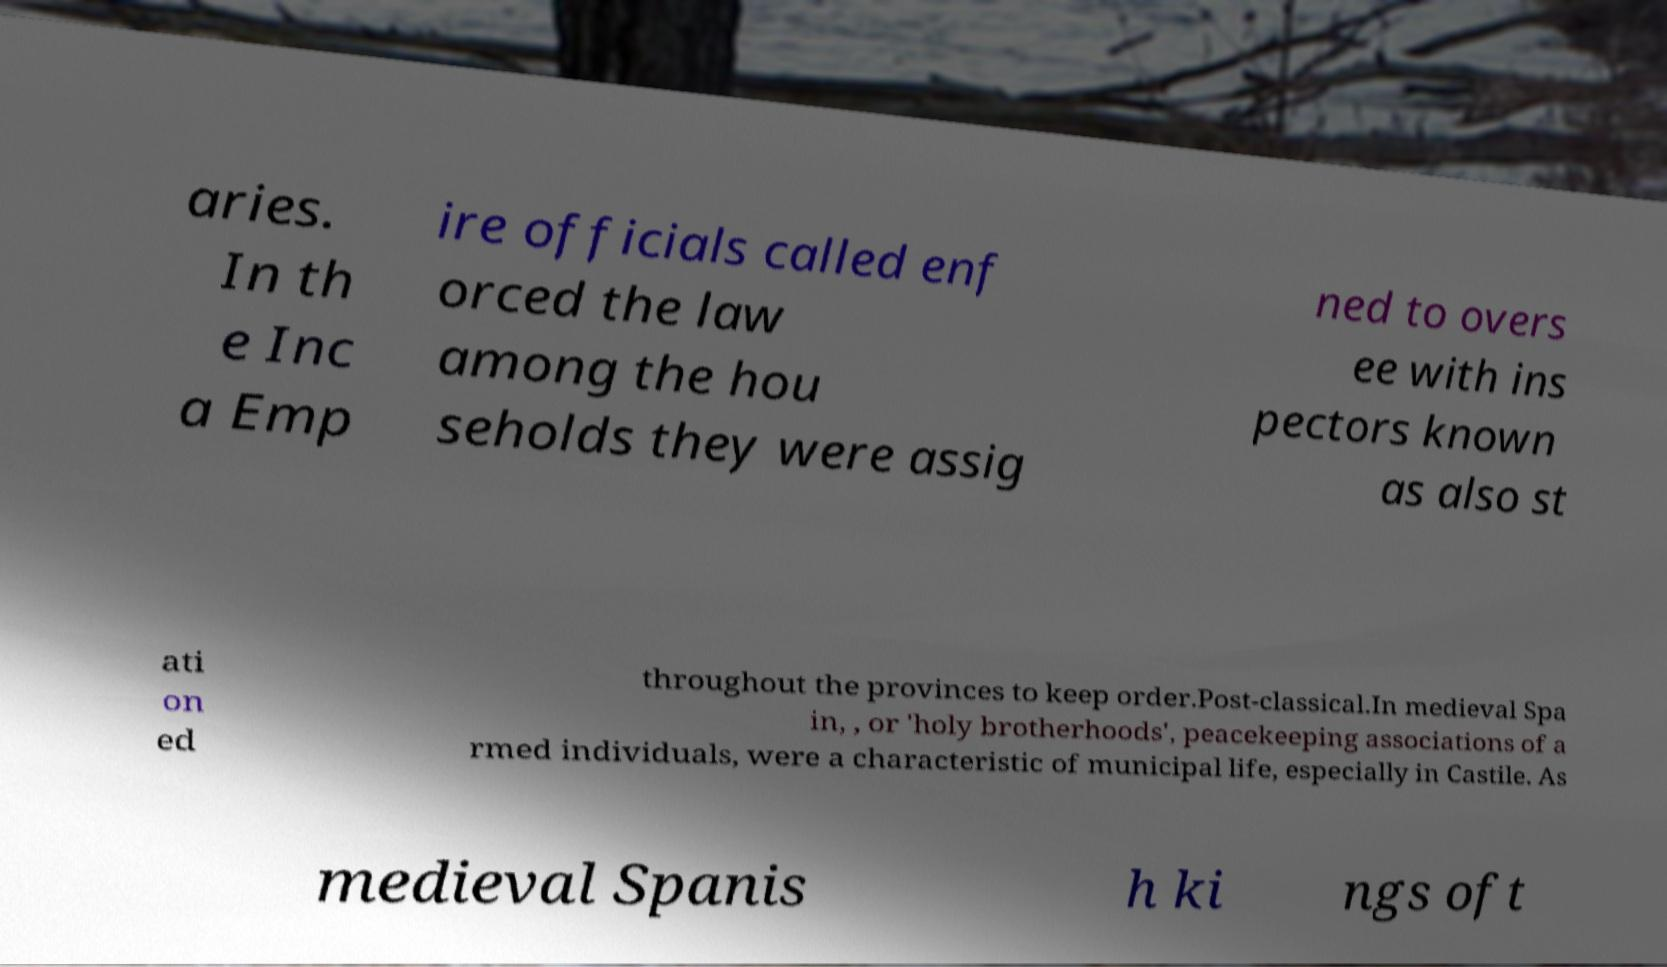Please identify and transcribe the text found in this image. aries. In th e Inc a Emp ire officials called enf orced the law among the hou seholds they were assig ned to overs ee with ins pectors known as also st ati on ed throughout the provinces to keep order.Post-classical.In medieval Spa in, , or 'holy brotherhoods', peacekeeping associations of a rmed individuals, were a characteristic of municipal life, especially in Castile. As medieval Spanis h ki ngs oft 